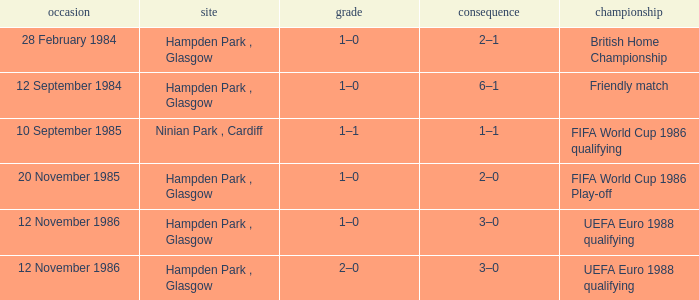What is the Score of the Fifa World Cup 1986 Qualifying Competition? 1–1. 